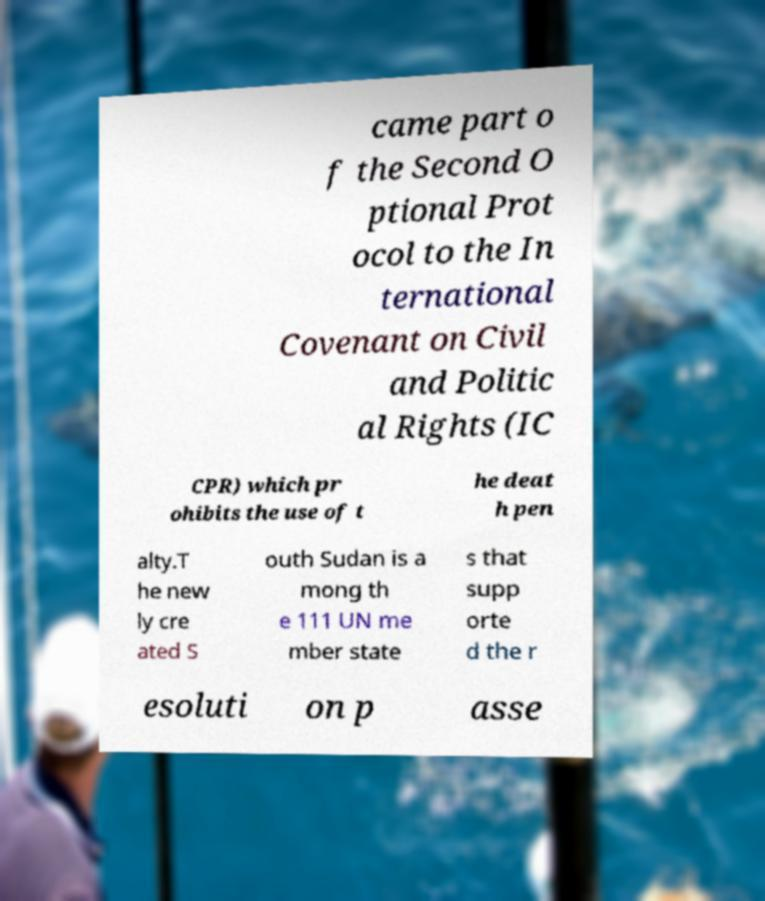Can you read and provide the text displayed in the image?This photo seems to have some interesting text. Can you extract and type it out for me? came part o f the Second O ptional Prot ocol to the In ternational Covenant on Civil and Politic al Rights (IC CPR) which pr ohibits the use of t he deat h pen alty.T he new ly cre ated S outh Sudan is a mong th e 111 UN me mber state s that supp orte d the r esoluti on p asse 